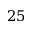Convert formula to latex. <formula><loc_0><loc_0><loc_500><loc_500>2 5</formula> 